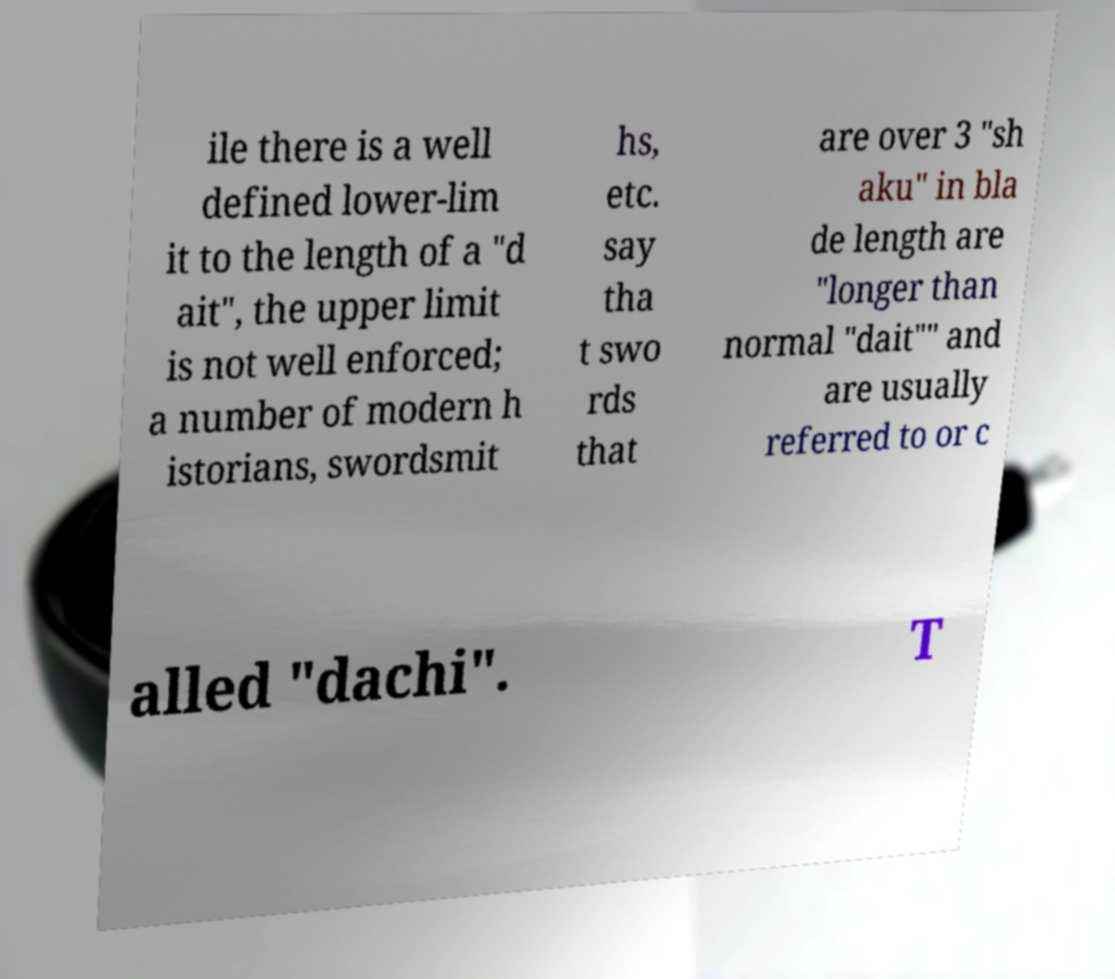Please read and relay the text visible in this image. What does it say? ile there is a well defined lower-lim it to the length of a "d ait", the upper limit is not well enforced; a number of modern h istorians, swordsmit hs, etc. say tha t swo rds that are over 3 "sh aku" in bla de length are "longer than normal "dait"" and are usually referred to or c alled "dachi". T 